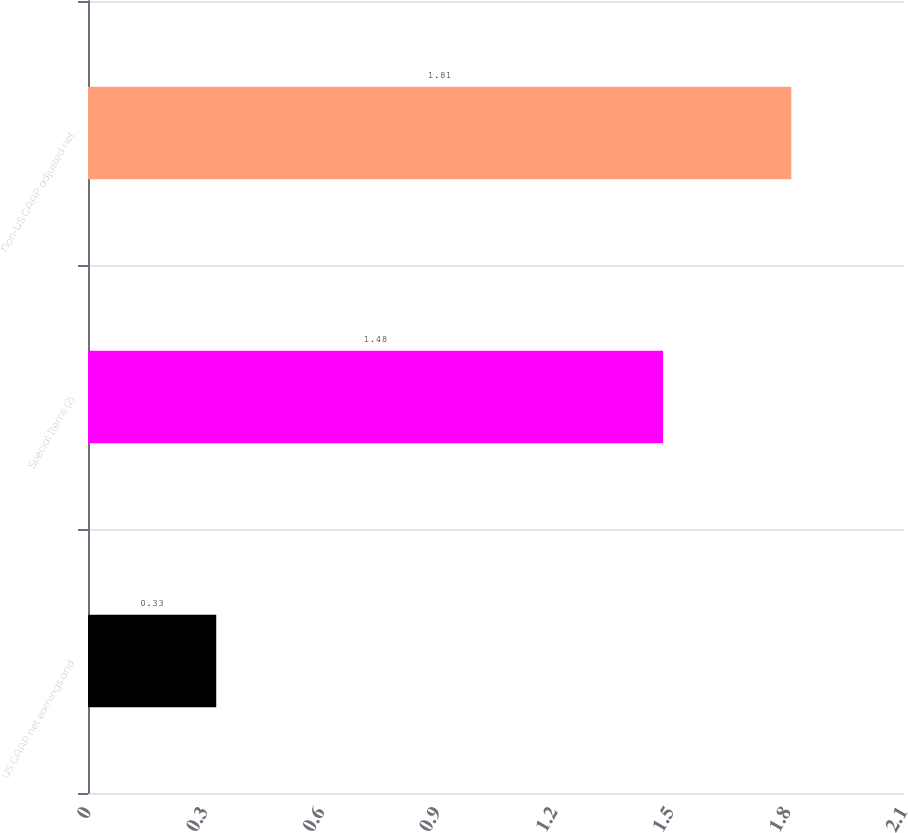Convert chart to OTSL. <chart><loc_0><loc_0><loc_500><loc_500><bar_chart><fcel>US GAAP net earnings and<fcel>Special Items (2)<fcel>Non-US GAAP adjusted net<nl><fcel>0.33<fcel>1.48<fcel>1.81<nl></chart> 